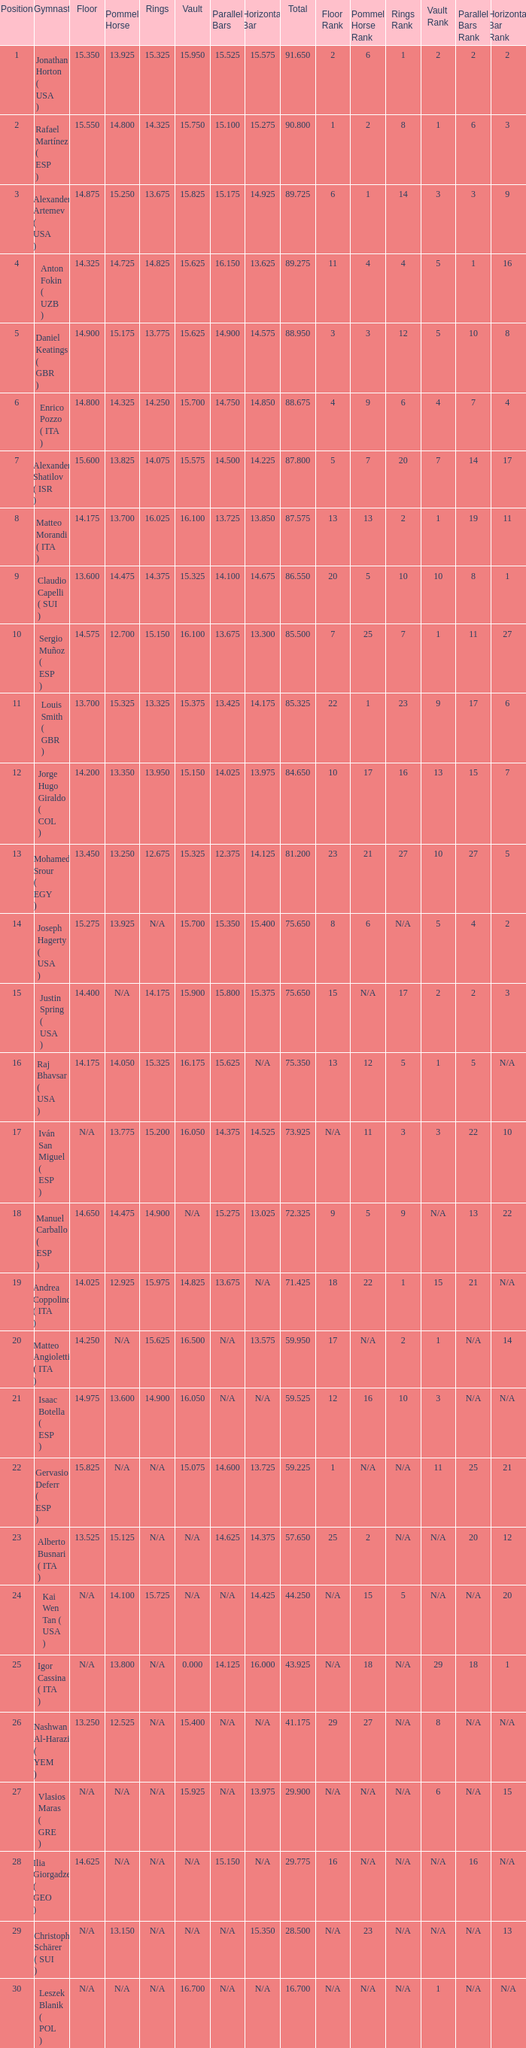If the floor number is 14.200, what is the number for the parallel bars? 14.025. Can you parse all the data within this table? {'header': ['Position', 'Gymnast', 'Floor', 'Pommel Horse', 'Rings', 'Vault', 'Parallel Bars', 'Horizontal Bar', 'Total', 'Floor Rank', 'Pommel Horse Rank', 'Rings Rank', 'Vault Rank', 'Parallel Bars Rank', 'Horizontal Bar Rank '], 'rows': [['1', 'Jonathan Horton ( USA )', '15.350', '13.925', '15.325', '15.950', '15.525', '15.575', '91.650', '2', '6', '1', '2', '2', '2 '], ['2', 'Rafael Martínez ( ESP )', '15.550', '14.800', '14.325', '15.750', '15.100', '15.275', '90.800', '1', '2', '8', '1', '6', '3 '], ['3', 'Alexander Artemev ( USA )', '14.875', '15.250', '13.675', '15.825', '15.175', '14.925', '89.725', '6', '1', '14', '3', '3', '9 '], ['4', 'Anton Fokin ( UZB )', '14.325', '14.725', '14.825', '15.625', '16.150', '13.625', '89.275', '11', '4', '4', '5', '1', '16 '], ['5', 'Daniel Keatings ( GBR )', '14.900', '15.175', '13.775', '15.625', '14.900', '14.575', '88.950', '3', '3', '12', '5', '10', '8 '], ['6', 'Enrico Pozzo ( ITA )', '14.800', '14.325', '14.250', '15.700', '14.750', '14.850', '88.675', '4', '9', '6', '4', '7', '4 '], ['7', 'Alexander Shatilov ( ISR )', '15.600', '13.825', '14.075', '15.575', '14.500', '14.225', '87.800', '5', '7', '20', '7', '14', '17 '], ['8', 'Matteo Morandi ( ITA )', '14.175', '13.700', '16.025', '16.100', '13.725', '13.850', '87.575', '13', '13', '2', '1', '19', '11 '], ['9', 'Claudio Capelli ( SUI )', '13.600', '14.475', '14.375', '15.325', '14.100', '14.675', '86.550', '20', '5', '10', '10', '8', '1 '], ['10', 'Sergio Muñoz ( ESP )', '14.575', '12.700', '15.150', '16.100', '13.675', '13.300', '85.500', '7', '25', '7', '1', '11', '27 '], ['11', 'Louis Smith ( GBR )', '13.700', '15.325', '13.325', '15.375', '13.425', '14.175', '85.325', '22', '1', '23', '9', '17', '6 '], ['12', 'Jorge Hugo Giraldo ( COL )', '14.200', '13.350', '13.950', '15.150', '14.025', '13.975', '84.650', '10', '17', '16', '13', '15', '7 '], ['13', 'Mohamed Srour ( EGY )', '13.450', '13.250', '12.675', '15.325', '12.375', '14.125', '81.200', '23', '21', '27', '10', '27', '5 '], ['14', 'Joseph Hagerty ( USA )', '15.275', '13.925', 'N/A', '15.700', '15.350', '15.400', '75.650', '8', '6', 'N/A', '5', '4', '2 '], ['15', 'Justin Spring ( USA )', '14.400', 'N/A', '14.175', '15.900', '15.800', '15.375', '75.650', '15', 'N/A', '17', '2', '2', '3 '], ['16', 'Raj Bhavsar ( USA )', '14.175', '14.050', '15.325', '16.175', '15.625', 'N/A', '75.350', '13', '12', '5', '1', '5', 'N/A '], ['17', 'Iván San Miguel ( ESP )', 'N/A', '13.775', '15.200', '16.050', '14.375', '14.525', '73.925', 'N/A', '11', '3', '3', '22', '10 '], ['18', 'Manuel Carballo ( ESP )', '14.650', '14.475', '14.900', 'N/A', '15.275', '13.025', '72.325', '9', '5', '9', 'N/A', '13', '22 '], ['19', 'Andrea Coppolino ( ITA )', '14.025', '12.925', '15.975', '14.825', '13.675', 'N/A', '71.425', '18', '22', '1', '15', '21', 'N/A '], ['20', 'Matteo Angioletti ( ITA )', '14.250', 'N/A', '15.625', '16.500', 'N/A', '13.575', '59.950', '17', 'N/A', '2', '1', 'N/A', '14 '], ['21', 'Isaac Botella ( ESP )', '14.975', '13.600', '14.900', '16.050', 'N/A', 'N/A', '59.525', '12', '16', '10', '3', 'N/A', 'N/A '], ['22', 'Gervasio Deferr ( ESP )', '15.825', 'N/A', 'N/A', '15.075', '14.600', '13.725', '59.225', '1', 'N/A', 'N/A', '11', '25', '21 '], ['23', 'Alberto Busnari ( ITA )', '13.525', '15.125', 'N/A', 'N/A', '14.625', '14.375', '57.650', '25', '2', 'N/A', 'N/A', '20', '12 '], ['24', 'Kai Wen Tan ( USA )', 'N/A', '14.100', '15.725', 'N/A', 'N/A', '14.425', '44.250', 'N/A', '15', '5', 'N/A', 'N/A', '20 '], ['25', 'Igor Cassina ( ITA )', 'N/A', '13.800', 'N/A', '0.000', '14.125', '16.000', '43.925', 'N/A', '18', 'N/A', '29', '18', '1 '], ['26', 'Nashwan Al-Harazi ( YEM )', '13.250', '12.525', 'N/A', '15.400', 'N/A', 'N/A', '41.175', '29', '27', 'N/A', '8', 'N/A', 'N/A '], ['27', 'Vlasios Maras ( GRE )', 'N/A', 'N/A', 'N/A', '15.925', 'N/A', '13.975', '29.900', 'N/A', 'N/A', 'N/A', '6', 'N/A', '15 '], ['28', 'Ilia Giorgadze ( GEO )', '14.625', 'N/A', 'N/A', 'N/A', '15.150', 'N/A', '29.775', '16', 'N/A', 'N/A', 'N/A', '16', 'N/A '], ['29', 'Christoph Schärer ( SUI )', 'N/A', '13.150', 'N/A', 'N/A', 'N/A', '15.350', '28.500', 'N/A', '23', 'N/A', 'N/A', 'N/A', '13 '], ['30', 'Leszek Blanik ( POL )', 'N/A', 'N/A', 'N/A', '16.700', 'N/A', 'N/A', '16.700', 'N/A', 'N/A', 'N/A', '1', 'N/A', 'N/A']]} 